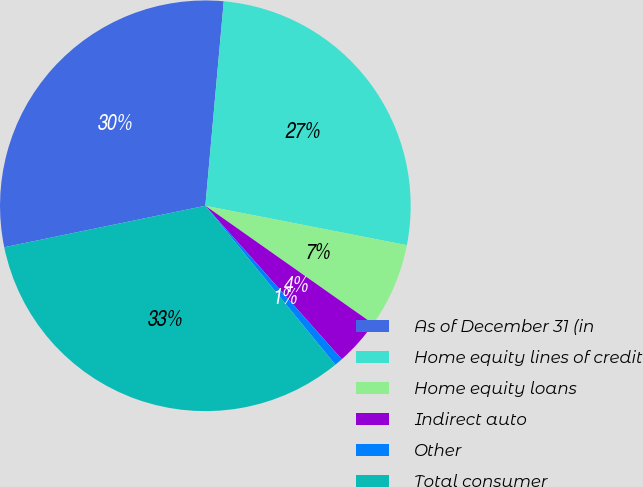<chart> <loc_0><loc_0><loc_500><loc_500><pie_chart><fcel>As of December 31 (in<fcel>Home equity lines of credit<fcel>Home equity loans<fcel>Indirect auto<fcel>Other<fcel>Total consumer<nl><fcel>29.66%<fcel>26.64%<fcel>6.69%<fcel>3.67%<fcel>0.66%<fcel>32.67%<nl></chart> 